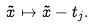Convert formula to latex. <formula><loc_0><loc_0><loc_500><loc_500>\tilde { x } \mapsto \tilde { x } - t _ { j } .</formula> 